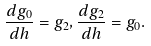<formula> <loc_0><loc_0><loc_500><loc_500>\frac { d g _ { 0 } } { d h } = g _ { 2 } , \frac { d g _ { 2 } } { d h } = g _ { 0 } .</formula> 